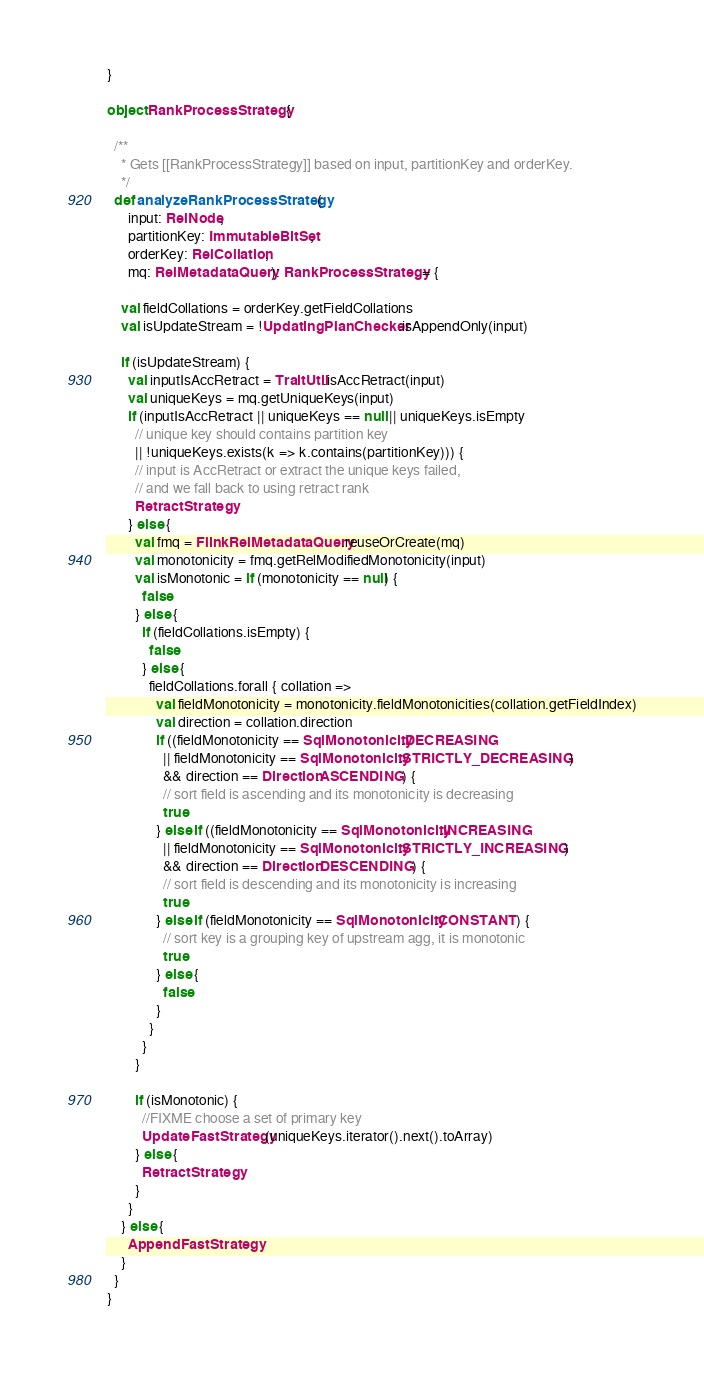<code> <loc_0><loc_0><loc_500><loc_500><_Scala_>}

object RankProcessStrategy {

  /**
    * Gets [[RankProcessStrategy]] based on input, partitionKey and orderKey.
    */
  def analyzeRankProcessStrategy(
      input: RelNode,
      partitionKey: ImmutableBitSet,
      orderKey: RelCollation,
      mq: RelMetadataQuery): RankProcessStrategy = {

    val fieldCollations = orderKey.getFieldCollations
    val isUpdateStream = !UpdatingPlanChecker.isAppendOnly(input)

    if (isUpdateStream) {
      val inputIsAccRetract = TraitUtil.isAccRetract(input)
      val uniqueKeys = mq.getUniqueKeys(input)
      if (inputIsAccRetract || uniqueKeys == null || uniqueKeys.isEmpty
        // unique key should contains partition key
        || !uniqueKeys.exists(k => k.contains(partitionKey))) {
        // input is AccRetract or extract the unique keys failed,
        // and we fall back to using retract rank
        RetractStrategy
      } else {
        val fmq = FlinkRelMetadataQuery.reuseOrCreate(mq)
        val monotonicity = fmq.getRelModifiedMonotonicity(input)
        val isMonotonic = if (monotonicity == null) {
          false
        } else {
          if (fieldCollations.isEmpty) {
            false
          } else {
            fieldCollations.forall { collation =>
              val fieldMonotonicity = monotonicity.fieldMonotonicities(collation.getFieldIndex)
              val direction = collation.direction
              if ((fieldMonotonicity == SqlMonotonicity.DECREASING
                || fieldMonotonicity == SqlMonotonicity.STRICTLY_DECREASING)
                && direction == Direction.ASCENDING) {
                // sort field is ascending and its monotonicity is decreasing
                true
              } else if ((fieldMonotonicity == SqlMonotonicity.INCREASING
                || fieldMonotonicity == SqlMonotonicity.STRICTLY_INCREASING)
                && direction == Direction.DESCENDING) {
                // sort field is descending and its monotonicity is increasing
                true
              } else if (fieldMonotonicity == SqlMonotonicity.CONSTANT) {
                // sort key is a grouping key of upstream agg, it is monotonic
                true
              } else {
                false
              }
            }
          }
        }

        if (isMonotonic) {
          //FIXME choose a set of primary key
          UpdateFastStrategy(uniqueKeys.iterator().next().toArray)
        } else {
          RetractStrategy
        }
      }
    } else {
      AppendFastStrategy
    }
  }
}
</code> 